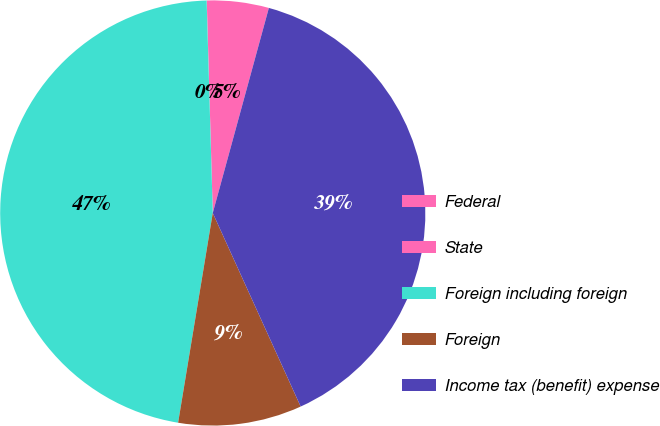<chart> <loc_0><loc_0><loc_500><loc_500><pie_chart><fcel>Federal<fcel>State<fcel>Foreign including foreign<fcel>Foreign<fcel>Income tax (benefit) expense<nl><fcel>4.7%<fcel>0.01%<fcel>46.93%<fcel>9.39%<fcel>38.96%<nl></chart> 